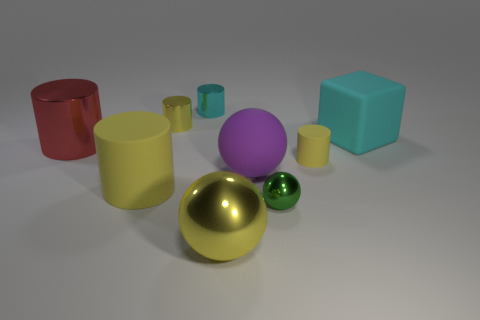Subtract all big yellow shiny spheres. How many spheres are left? 2 Subtract all yellow spheres. How many spheres are left? 2 Subtract all cyan cylinders. How many yellow balls are left? 1 Subtract all large purple rubber objects. Subtract all small green spheres. How many objects are left? 7 Add 1 purple balls. How many purple balls are left? 2 Add 4 yellow shiny cylinders. How many yellow shiny cylinders exist? 5 Subtract 1 purple balls. How many objects are left? 8 Subtract all cubes. How many objects are left? 8 Subtract 2 balls. How many balls are left? 1 Subtract all yellow balls. Subtract all gray cylinders. How many balls are left? 2 